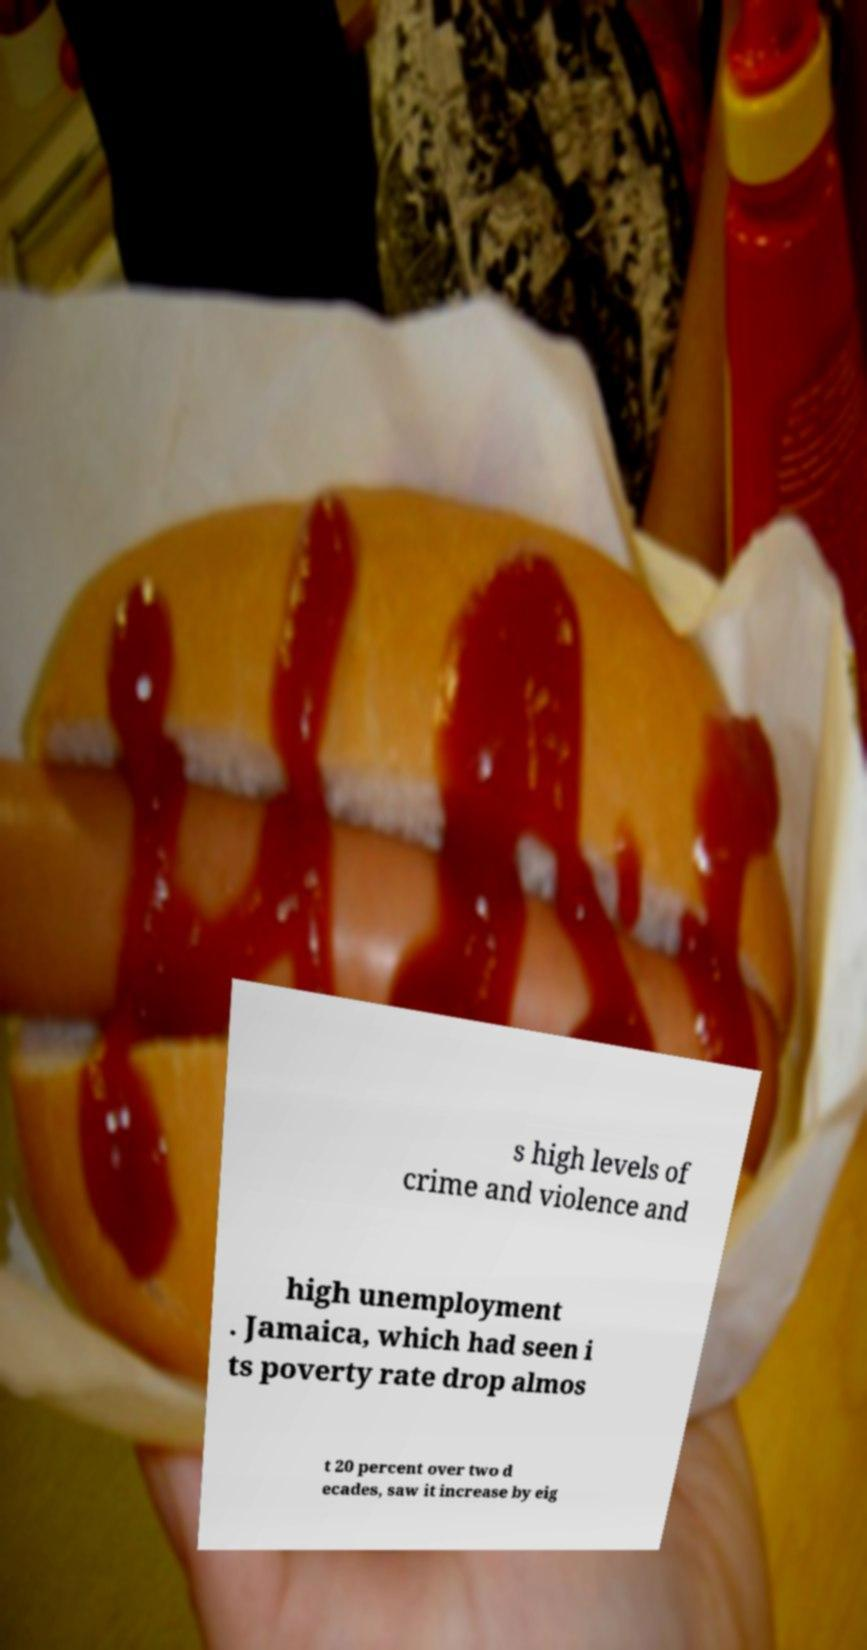I need the written content from this picture converted into text. Can you do that? s high levels of crime and violence and high unemployment . Jamaica, which had seen i ts poverty rate drop almos t 20 percent over two d ecades, saw it increase by eig 